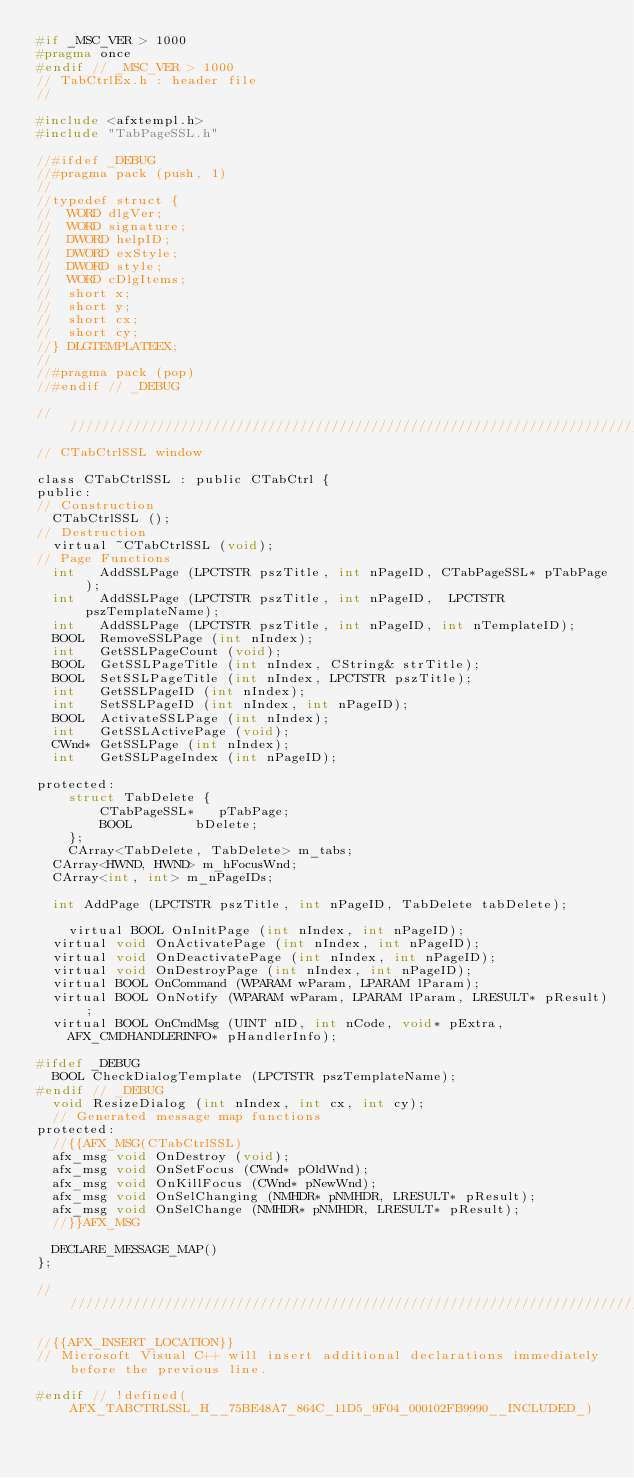<code> <loc_0><loc_0><loc_500><loc_500><_C_>#if _MSC_VER > 1000
#pragma once
#endif // _MSC_VER > 1000
// TabCtrlEx.h : header file
//

#include <afxtempl.h>
#include "TabPageSSL.h"

//#ifdef _DEBUG
//#pragma pack (push, 1)
//
//typedef struct {
//	WORD dlgVer;
//	WORD signature;
//	DWORD helpID;
//	DWORD exStyle;
//	DWORD style;
//	WORD cDlgItems;
//	short x;
//	short y;
//	short cx;
//	short cy;
//} DLGTEMPLATEEX;
//
//#pragma pack (pop)
//#endif // _DEBUG

/////////////////////////////////////////////////////////////////////////////
// CTabCtrlSSL window

class CTabCtrlSSL : public CTabCtrl {
public:
// Construction
	CTabCtrlSSL ();
// Destruction
	virtual ~CTabCtrlSSL (void);
// Page Functions
	int		AddSSLPage (LPCTSTR pszTitle, int nPageID, CTabPageSSL* pTabPage);
	int		AddSSLPage (LPCTSTR pszTitle, int nPageID,	LPCTSTR pszTemplateName);
	int		AddSSLPage (LPCTSTR pszTitle, int nPageID, int nTemplateID);
	BOOL	RemoveSSLPage (int nIndex);
	int		GetSSLPageCount (void);
	BOOL	GetSSLPageTitle (int nIndex, CString& strTitle);
	BOOL	SetSSLPageTitle (int nIndex, LPCTSTR pszTitle);
	int		GetSSLPageID (int nIndex);
	int		SetSSLPageID (int nIndex, int nPageID);
	BOOL	ActivateSSLPage (int nIndex);
	int		GetSSLActivePage (void);
	CWnd*	GetSSLPage (int nIndex);
	int		GetSSLPageIndex (int nPageID);

protected:
    struct TabDelete {
        CTabPageSSL*   pTabPage;
        BOOL        bDelete;
    };
    CArray<TabDelete, TabDelete> m_tabs;
	CArray<HWND, HWND> m_hFocusWnd;
	CArray<int, int> m_nPageIDs;

	int AddPage (LPCTSTR pszTitle, int nPageID, TabDelete tabDelete);

    virtual BOOL OnInitPage (int nIndex, int nPageID);
	virtual void OnActivatePage (int nIndex, int nPageID);
	virtual void OnDeactivatePage (int nIndex, int nPageID);
	virtual void OnDestroyPage (int nIndex, int nPageID);
	virtual BOOL OnCommand (WPARAM wParam, LPARAM lParam);
	virtual BOOL OnNotify (WPARAM wParam, LPARAM lParam, LRESULT* pResult);
	virtual BOOL OnCmdMsg (UINT nID, int nCode, void* pExtra,
		AFX_CMDHANDLERINFO* pHandlerInfo);

#ifdef _DEBUG
	BOOL CheckDialogTemplate (LPCTSTR pszTemplateName);
#endif // _DEBUG
	void ResizeDialog (int nIndex, int cx, int cy);
	// Generated message map functions
protected:
	//{{AFX_MSG(CTabCtrlSSL)
	afx_msg void OnDestroy (void);
	afx_msg void OnSetFocus (CWnd* pOldWnd);
	afx_msg void OnKillFocus (CWnd* pNewWnd);
	afx_msg void OnSelChanging (NMHDR* pNMHDR, LRESULT* pResult);
	afx_msg void OnSelChange (NMHDR* pNMHDR, LRESULT* pResult);
	//}}AFX_MSG

	DECLARE_MESSAGE_MAP()
};

/////////////////////////////////////////////////////////////////////////////

//{{AFX_INSERT_LOCATION}}
// Microsoft Visual C++ will insert additional declarations immediately before the previous line.

#endif // !defined(AFX_TABCTRLSSL_H__75BE48A7_864C_11D5_9F04_000102FB9990__INCLUDED_)
</code> 